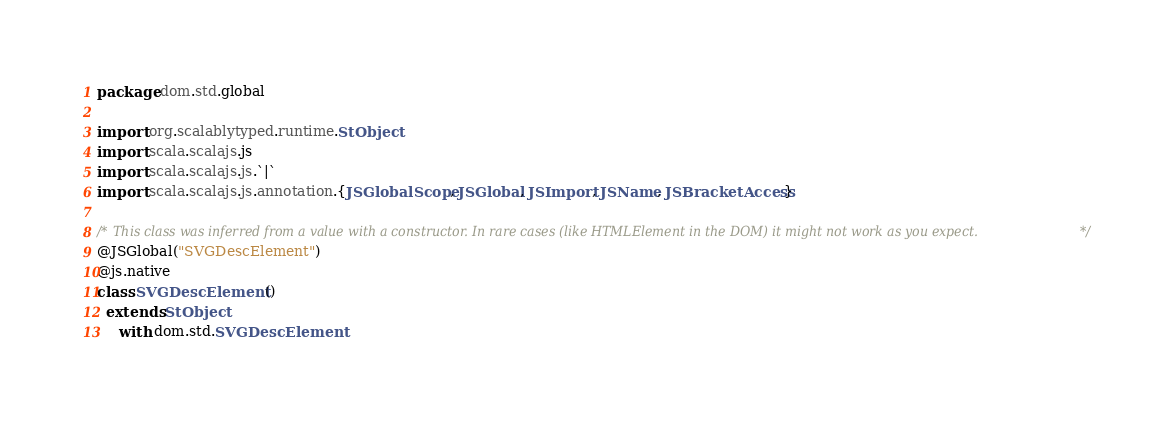<code> <loc_0><loc_0><loc_500><loc_500><_Scala_>package dom.std.global

import org.scalablytyped.runtime.StObject
import scala.scalajs.js
import scala.scalajs.js.`|`
import scala.scalajs.js.annotation.{JSGlobalScope, JSGlobal, JSImport, JSName, JSBracketAccess}

/* This class was inferred from a value with a constructor. In rare cases (like HTMLElement in the DOM) it might not work as you expect. */
@JSGlobal("SVGDescElement")
@js.native
class SVGDescElement ()
  extends StObject
     with dom.std.SVGDescElement
</code> 